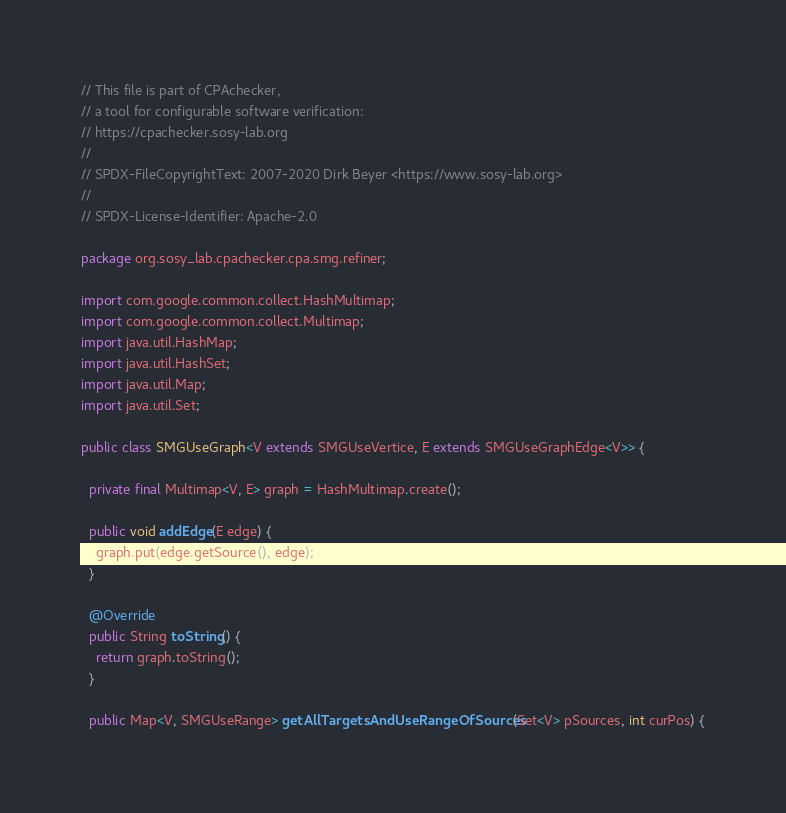<code> <loc_0><loc_0><loc_500><loc_500><_Java_>// This file is part of CPAchecker,
// a tool for configurable software verification:
// https://cpachecker.sosy-lab.org
//
// SPDX-FileCopyrightText: 2007-2020 Dirk Beyer <https://www.sosy-lab.org>
//
// SPDX-License-Identifier: Apache-2.0

package org.sosy_lab.cpachecker.cpa.smg.refiner;

import com.google.common.collect.HashMultimap;
import com.google.common.collect.Multimap;
import java.util.HashMap;
import java.util.HashSet;
import java.util.Map;
import java.util.Set;

public class SMGUseGraph<V extends SMGUseVertice, E extends SMGUseGraphEdge<V>> {

  private final Multimap<V, E> graph = HashMultimap.create();

  public void addEdge(E edge) {
    graph.put(edge.getSource(), edge);
  }

  @Override
  public String toString() {
    return graph.toString();
  }

  public Map<V, SMGUseRange> getAllTargetsAndUseRangeOfSources(Set<V> pSources, int curPos) {
</code> 